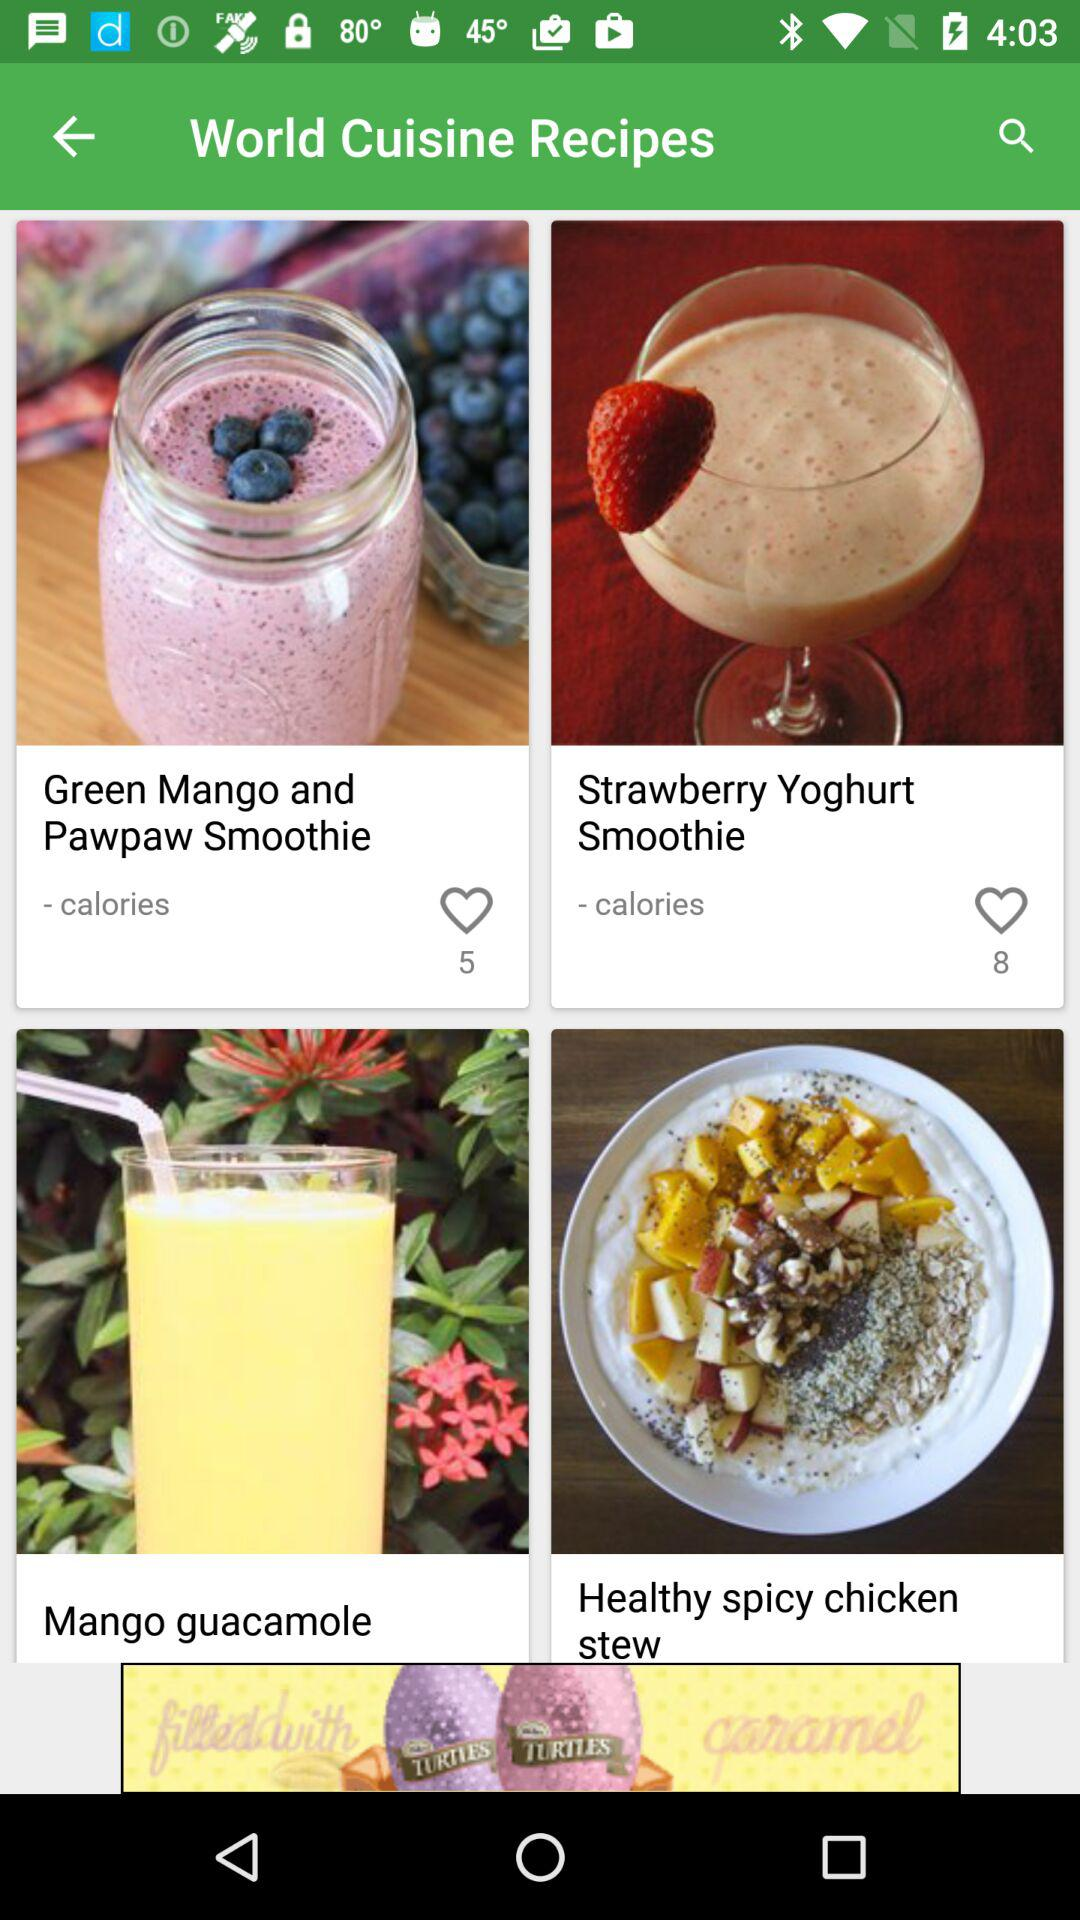How many people liked the "Strawberry Yoghurt Smoothie"? The "Strawberry Yoghurt Smoothie" was liked by 8 people. 